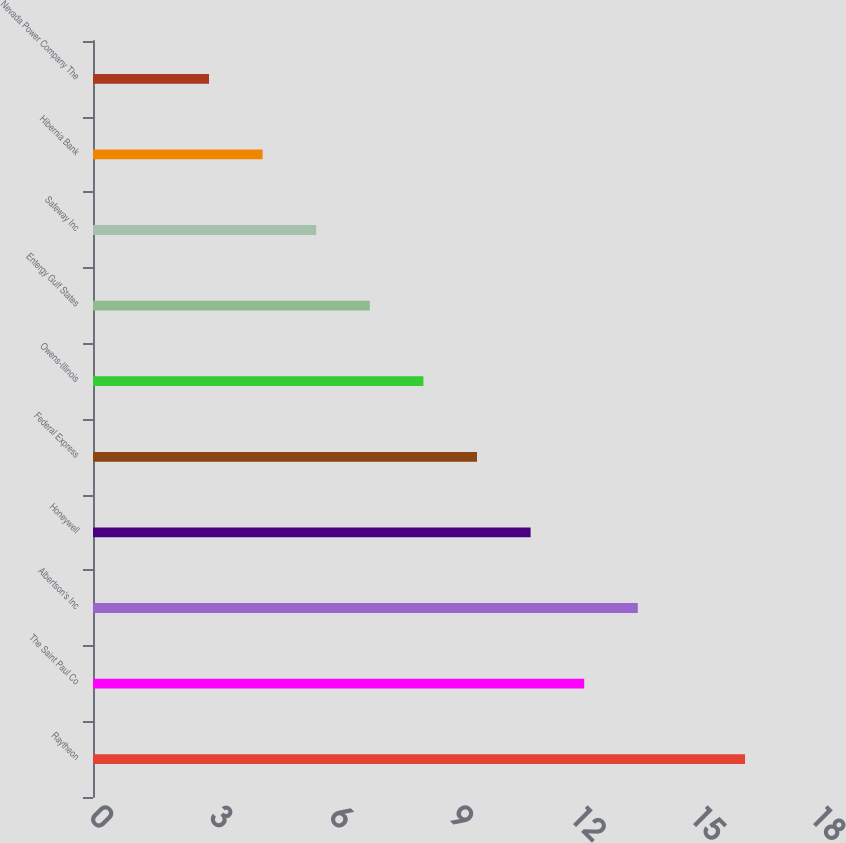<chart> <loc_0><loc_0><loc_500><loc_500><bar_chart><fcel>Raytheon<fcel>The Saint Paul Co<fcel>Albertson's Inc<fcel>Honeywell<fcel>Federal Express<fcel>Owens-Illinois<fcel>Entergy Gulf States<fcel>Safeway Inc<fcel>Hibernia Bank<fcel>Nevada Power Company The<nl><fcel>16.3<fcel>12.28<fcel>13.62<fcel>10.94<fcel>9.6<fcel>8.26<fcel>6.92<fcel>5.58<fcel>4.24<fcel>2.9<nl></chart> 